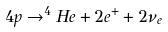Convert formula to latex. <formula><loc_0><loc_0><loc_500><loc_500>4 p \rightarrow ^ { 4 } H e + 2 e ^ { + } + 2 \nu _ { e }</formula> 